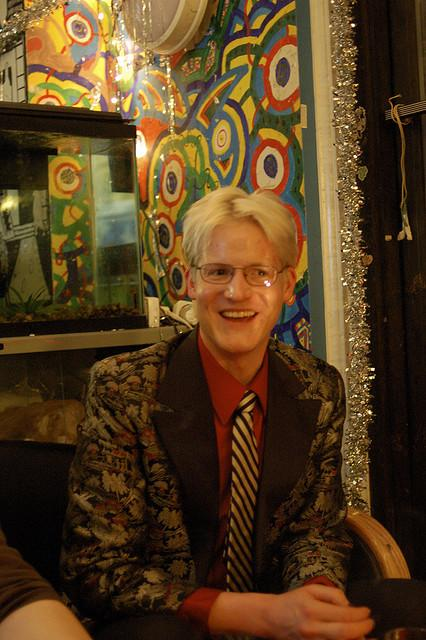What is the gold lining in the doorway called? Please explain your reasoning. ermine. The gold lining on the door is a shiny material called tinsel often seen on christmas trees. 